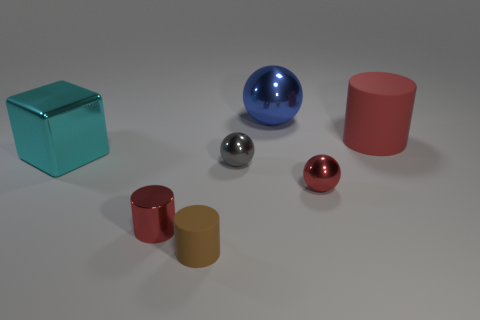Are there the same number of big shiny things that are in front of the shiny cylinder and blue metal balls?
Offer a very short reply. No. What number of other objects are there of the same color as the shiny cylinder?
Keep it short and to the point. 2. There is a cylinder that is right of the tiny red cylinder and behind the small brown object; what color is it?
Give a very brief answer. Red. There is a matte thing on the left side of the small ball to the right of the shiny thing behind the big shiny block; what is its size?
Give a very brief answer. Small. What number of things are either balls that are in front of the big cyan metal thing or cylinders that are on the right side of the blue ball?
Offer a terse response. 3. The large cyan shiny thing is what shape?
Offer a terse response. Cube. How many other objects are there of the same material as the brown thing?
Ensure brevity in your answer.  1. What is the size of the red shiny thing that is the same shape as the gray thing?
Offer a terse response. Small. The cylinder behind the big thing that is in front of the cylinder that is behind the metallic cube is made of what material?
Keep it short and to the point. Rubber. Are there any matte balls?
Your answer should be very brief. No. 